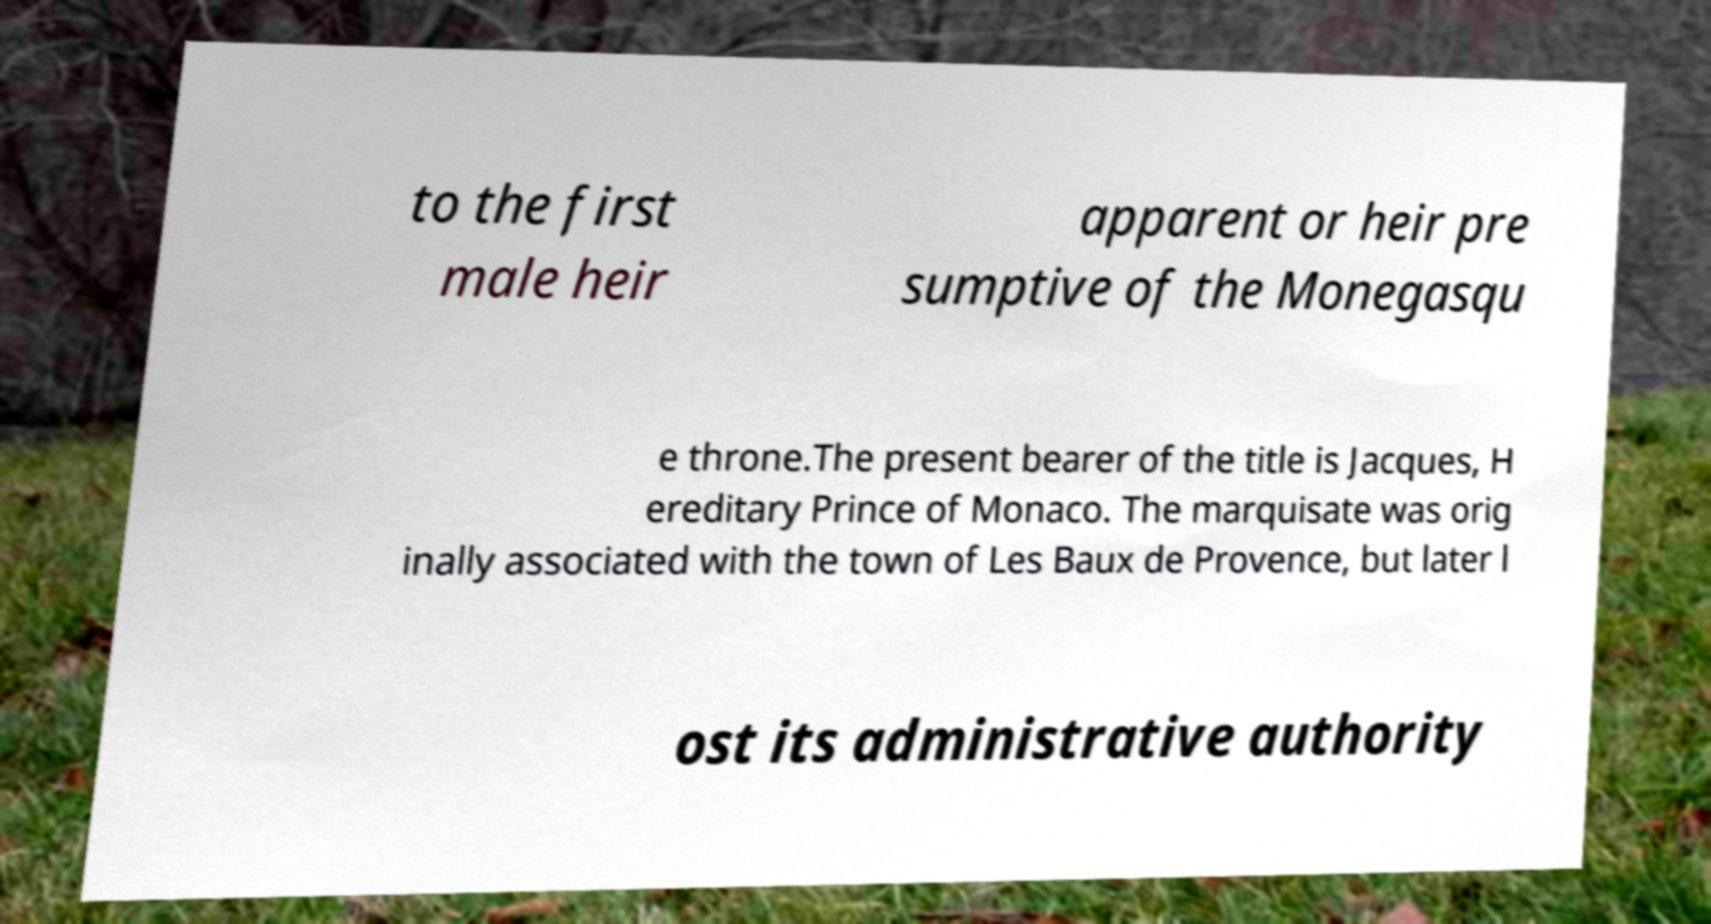Could you extract and type out the text from this image? to the first male heir apparent or heir pre sumptive of the Monegasqu e throne.The present bearer of the title is Jacques, H ereditary Prince of Monaco. The marquisate was orig inally associated with the town of Les Baux de Provence, but later l ost its administrative authority 